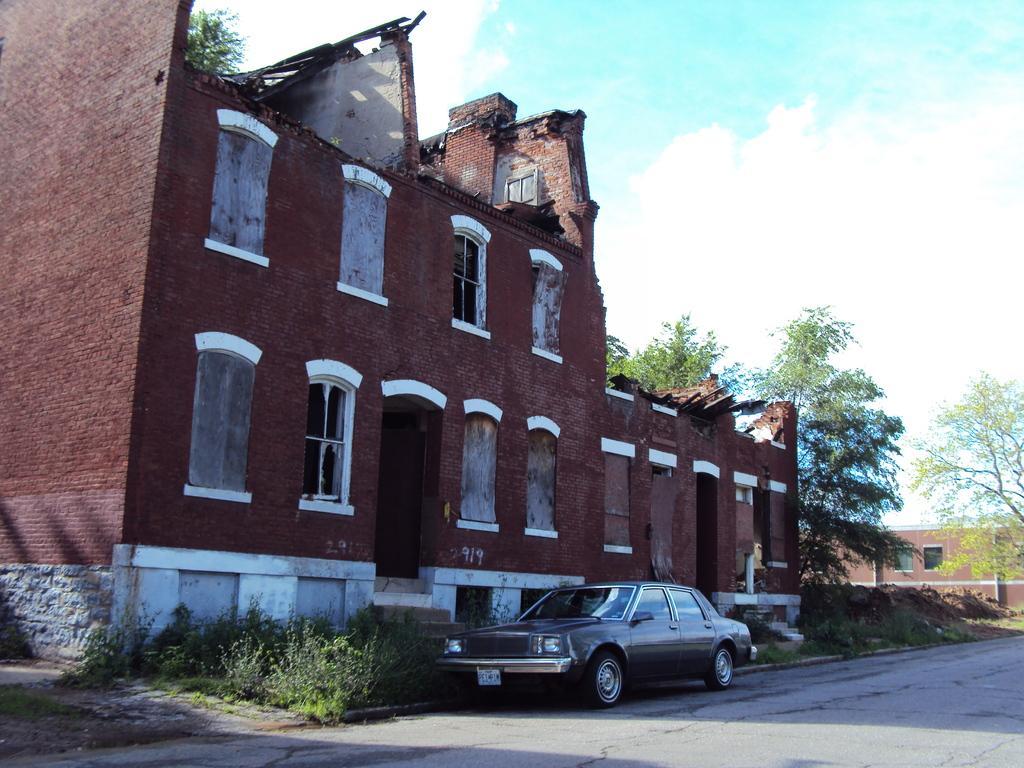Describe this image in one or two sentences. In this image we can see few buildings and there is a car on the road and we can see some plants and trees and at the top we can see the sky with clouds. 